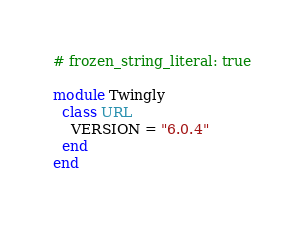<code> <loc_0><loc_0><loc_500><loc_500><_Ruby_># frozen_string_literal: true

module Twingly
  class URL
    VERSION = "6.0.4"
  end
end
</code> 